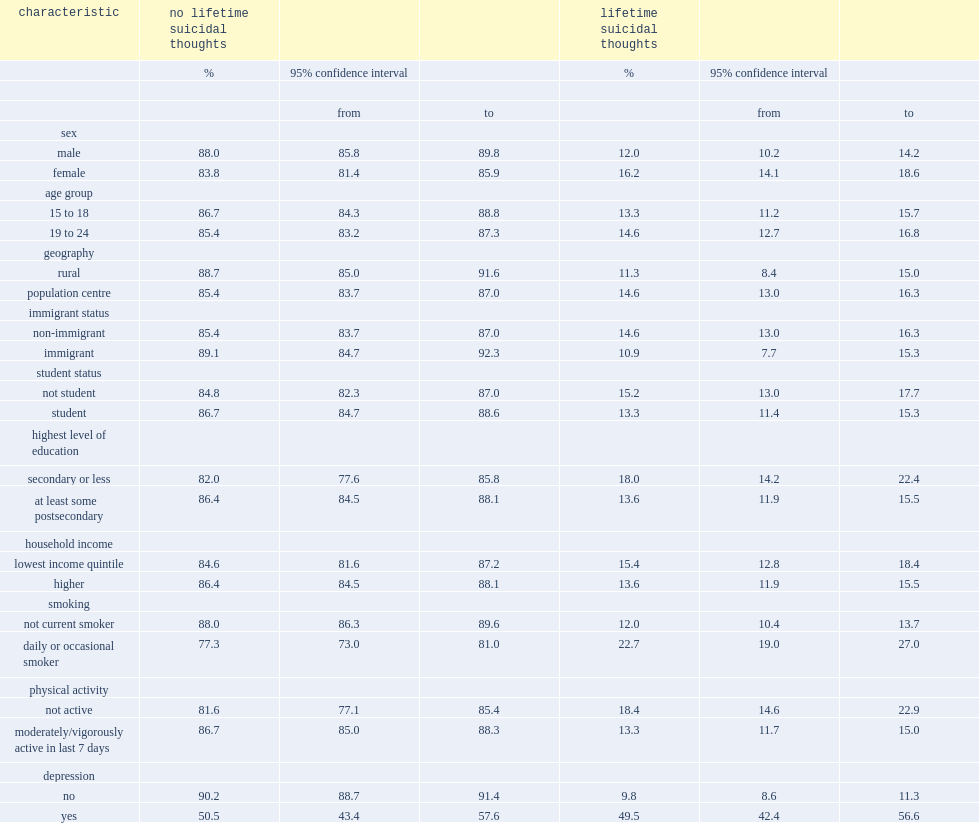Who are more likely to have lifetime suicidal thoughts ,males or females? Female. 